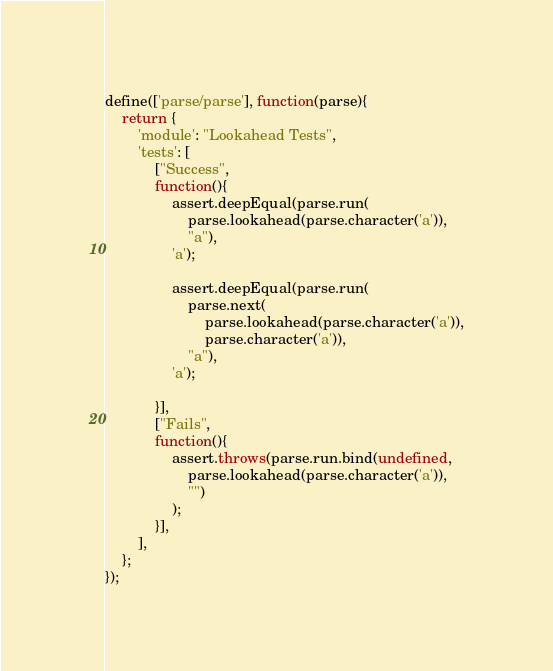<code> <loc_0><loc_0><loc_500><loc_500><_JavaScript_>define(['parse/parse'], function(parse){
    return {
        'module': "Lookahead Tests",
        'tests': [
            ["Success",
            function(){
                assert.deepEqual(parse.run(
                    parse.lookahead(parse.character('a')),
                    "a"),
                'a');
                
                assert.deepEqual(parse.run(
                    parse.next(
                        parse.lookahead(parse.character('a')),
                        parse.character('a')),
                    "a"),
                'a');
                
            }],
            ["Fails",
            function(){
                assert.throws(parse.run.bind(undefined,
                    parse.lookahead(parse.character('a')),
                    "")
                );
            }],
        ],
    };
});
</code> 